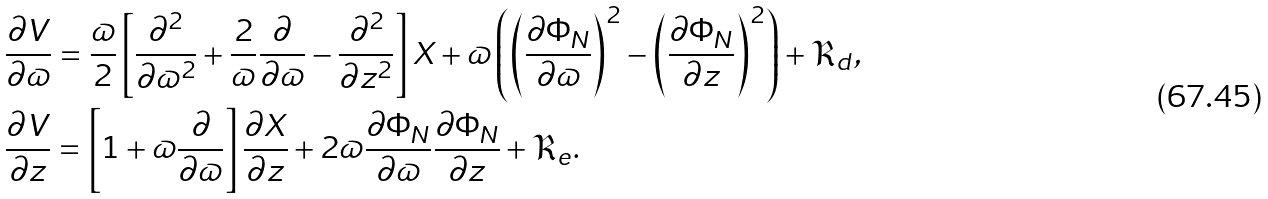Convert formula to latex. <formula><loc_0><loc_0><loc_500><loc_500>& \frac { \partial V } { \partial \varpi } = \frac { \varpi } { 2 } \left [ \frac { \partial ^ { 2 } } { \partial \varpi ^ { 2 } } + \frac { 2 } { \varpi } \frac { \partial } { \partial \varpi } - \frac { \partial ^ { 2 } } { \partial z ^ { 2 } } \right ] X + \varpi \left ( \left ( \frac { \partial \Phi _ { N } } { \partial \varpi } \right ) ^ { 2 } - \left ( \frac { \partial \Phi _ { N } } { \partial z } \right ) ^ { 2 } \right ) + \mathfrak { R } _ { d } , \\ & \frac { \partial V } { \partial z } = \left [ 1 + \varpi \frac { \partial } { \partial \varpi } \right ] \frac { \partial X } { \partial z } + 2 \varpi \frac { \partial \Phi _ { N } } { \partial \varpi } \frac { \partial \Phi _ { N } } { \partial z } + \mathfrak { R } _ { e } .</formula> 